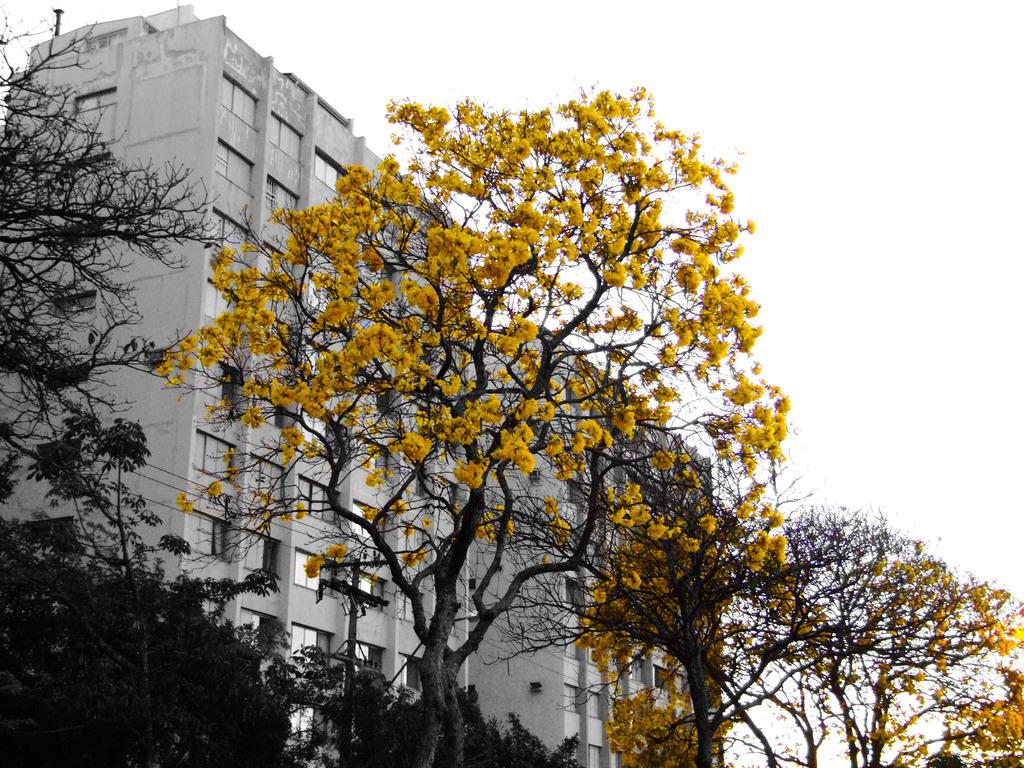What type of vegetation is present in the image? There are trees with flowers in the image. What is connected to the wires in the image? There is a pole connected with wires in the image. What can be seen in the distance in the image? There are buildings visible in the background of the image. What is visible at the top of the image? The sky is visible at the top of the image. How many trains are visible in the image? There are no trains present in the image. What type of rail is connected to the pole in the image? There is no rail connected to the pole in the image; it is connected to wires. 